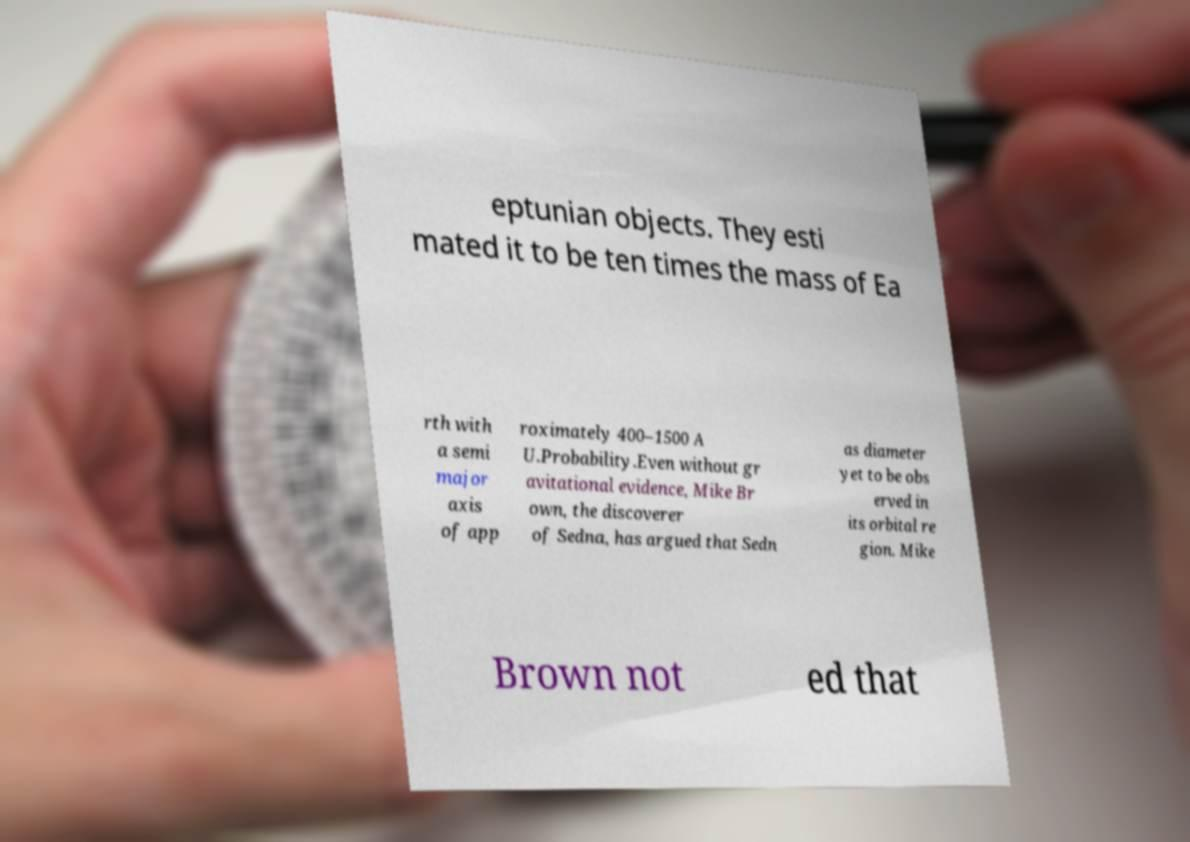Could you extract and type out the text from this image? eptunian objects. They esti mated it to be ten times the mass of Ea rth with a semi major axis of app roximately 400–1500 A U.Probability.Even without gr avitational evidence, Mike Br own, the discoverer of Sedna, has argued that Sedn as diameter yet to be obs erved in its orbital re gion. Mike Brown not ed that 